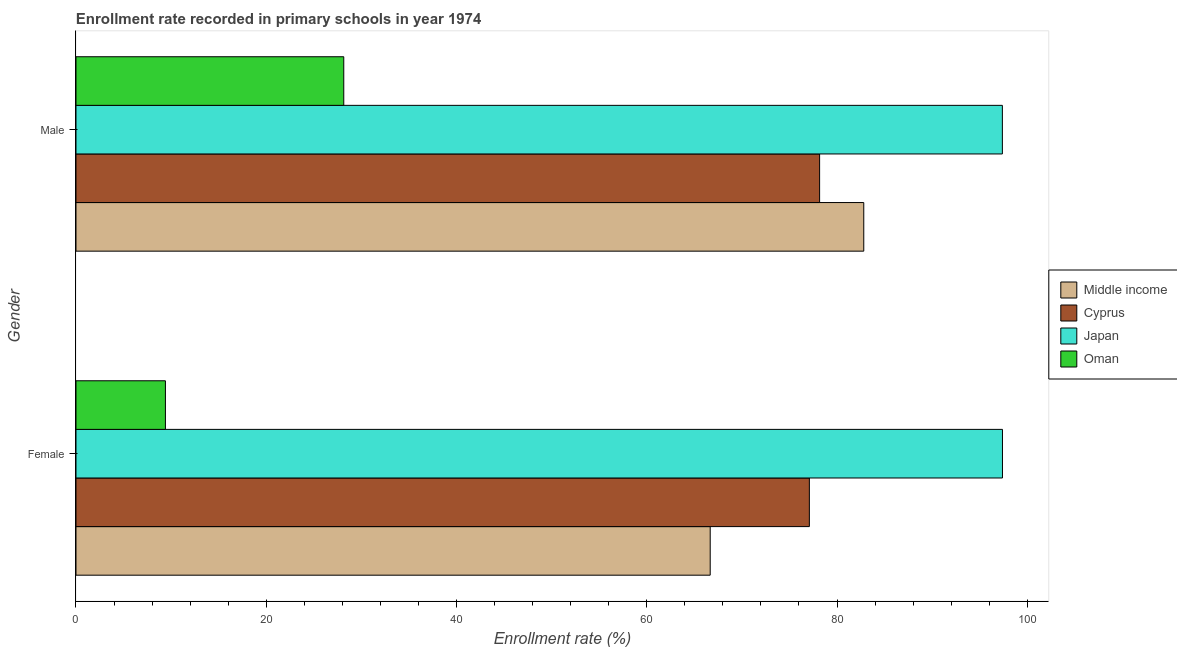How many bars are there on the 1st tick from the top?
Offer a terse response. 4. What is the label of the 1st group of bars from the top?
Your answer should be very brief. Male. What is the enrollment rate of female students in Cyprus?
Offer a very short reply. 77.09. Across all countries, what is the maximum enrollment rate of female students?
Ensure brevity in your answer.  97.39. Across all countries, what is the minimum enrollment rate of male students?
Ensure brevity in your answer.  28.15. In which country was the enrollment rate of male students minimum?
Offer a terse response. Oman. What is the total enrollment rate of female students in the graph?
Keep it short and to the point. 250.55. What is the difference between the enrollment rate of male students in Cyprus and that in Oman?
Offer a terse response. 50.02. What is the difference between the enrollment rate of male students in Middle income and the enrollment rate of female students in Cyprus?
Offer a terse response. 5.72. What is the average enrollment rate of female students per country?
Keep it short and to the point. 62.64. What is the difference between the enrollment rate of female students and enrollment rate of male students in Japan?
Your response must be concise. 0.01. In how many countries, is the enrollment rate of male students greater than 28 %?
Make the answer very short. 4. What is the ratio of the enrollment rate of male students in Cyprus to that in Middle income?
Offer a very short reply. 0.94. Is the enrollment rate of male students in Cyprus less than that in Japan?
Provide a succinct answer. Yes. In how many countries, is the enrollment rate of female students greater than the average enrollment rate of female students taken over all countries?
Your response must be concise. 3. How many bars are there?
Provide a short and direct response. 8. Are all the bars in the graph horizontal?
Your answer should be very brief. Yes. Are the values on the major ticks of X-axis written in scientific E-notation?
Ensure brevity in your answer.  No. Does the graph contain grids?
Ensure brevity in your answer.  No. How many legend labels are there?
Keep it short and to the point. 4. What is the title of the graph?
Provide a succinct answer. Enrollment rate recorded in primary schools in year 1974. What is the label or title of the X-axis?
Your answer should be very brief. Enrollment rate (%). What is the label or title of the Y-axis?
Give a very brief answer. Gender. What is the Enrollment rate (%) of Middle income in Female?
Provide a succinct answer. 66.67. What is the Enrollment rate (%) in Cyprus in Female?
Provide a short and direct response. 77.09. What is the Enrollment rate (%) of Japan in Female?
Provide a short and direct response. 97.39. What is the Enrollment rate (%) of Oman in Female?
Provide a succinct answer. 9.4. What is the Enrollment rate (%) of Middle income in Male?
Give a very brief answer. 82.81. What is the Enrollment rate (%) of Cyprus in Male?
Provide a short and direct response. 78.17. What is the Enrollment rate (%) of Japan in Male?
Make the answer very short. 97.38. What is the Enrollment rate (%) in Oman in Male?
Offer a terse response. 28.15. Across all Gender, what is the maximum Enrollment rate (%) of Middle income?
Provide a succinct answer. 82.81. Across all Gender, what is the maximum Enrollment rate (%) in Cyprus?
Make the answer very short. 78.17. Across all Gender, what is the maximum Enrollment rate (%) of Japan?
Provide a short and direct response. 97.39. Across all Gender, what is the maximum Enrollment rate (%) in Oman?
Your response must be concise. 28.15. Across all Gender, what is the minimum Enrollment rate (%) in Middle income?
Your answer should be very brief. 66.67. Across all Gender, what is the minimum Enrollment rate (%) of Cyprus?
Offer a terse response. 77.09. Across all Gender, what is the minimum Enrollment rate (%) of Japan?
Provide a succinct answer. 97.38. Across all Gender, what is the minimum Enrollment rate (%) of Oman?
Provide a succinct answer. 9.4. What is the total Enrollment rate (%) in Middle income in the graph?
Offer a very short reply. 149.48. What is the total Enrollment rate (%) of Cyprus in the graph?
Your answer should be very brief. 155.26. What is the total Enrollment rate (%) of Japan in the graph?
Ensure brevity in your answer.  194.77. What is the total Enrollment rate (%) of Oman in the graph?
Offer a terse response. 37.55. What is the difference between the Enrollment rate (%) of Middle income in Female and that in Male?
Offer a very short reply. -16.14. What is the difference between the Enrollment rate (%) of Cyprus in Female and that in Male?
Make the answer very short. -1.08. What is the difference between the Enrollment rate (%) in Japan in Female and that in Male?
Ensure brevity in your answer.  0.01. What is the difference between the Enrollment rate (%) of Oman in Female and that in Male?
Provide a short and direct response. -18.75. What is the difference between the Enrollment rate (%) in Middle income in Female and the Enrollment rate (%) in Japan in Male?
Offer a very short reply. -30.71. What is the difference between the Enrollment rate (%) of Middle income in Female and the Enrollment rate (%) of Oman in Male?
Ensure brevity in your answer.  38.52. What is the difference between the Enrollment rate (%) of Cyprus in Female and the Enrollment rate (%) of Japan in Male?
Your answer should be very brief. -20.29. What is the difference between the Enrollment rate (%) of Cyprus in Female and the Enrollment rate (%) of Oman in Male?
Give a very brief answer. 48.94. What is the difference between the Enrollment rate (%) in Japan in Female and the Enrollment rate (%) in Oman in Male?
Provide a succinct answer. 69.24. What is the average Enrollment rate (%) of Middle income per Gender?
Your answer should be very brief. 74.74. What is the average Enrollment rate (%) in Cyprus per Gender?
Provide a succinct answer. 77.63. What is the average Enrollment rate (%) of Japan per Gender?
Offer a very short reply. 97.39. What is the average Enrollment rate (%) of Oman per Gender?
Your response must be concise. 18.77. What is the difference between the Enrollment rate (%) in Middle income and Enrollment rate (%) in Cyprus in Female?
Your answer should be very brief. -10.42. What is the difference between the Enrollment rate (%) in Middle income and Enrollment rate (%) in Japan in Female?
Your response must be concise. -30.72. What is the difference between the Enrollment rate (%) in Middle income and Enrollment rate (%) in Oman in Female?
Offer a terse response. 57.27. What is the difference between the Enrollment rate (%) of Cyprus and Enrollment rate (%) of Japan in Female?
Your answer should be compact. -20.3. What is the difference between the Enrollment rate (%) of Cyprus and Enrollment rate (%) of Oman in Female?
Keep it short and to the point. 67.69. What is the difference between the Enrollment rate (%) of Japan and Enrollment rate (%) of Oman in Female?
Provide a short and direct response. 87.99. What is the difference between the Enrollment rate (%) in Middle income and Enrollment rate (%) in Cyprus in Male?
Make the answer very short. 4.64. What is the difference between the Enrollment rate (%) of Middle income and Enrollment rate (%) of Japan in Male?
Offer a very short reply. -14.57. What is the difference between the Enrollment rate (%) in Middle income and Enrollment rate (%) in Oman in Male?
Your response must be concise. 54.66. What is the difference between the Enrollment rate (%) of Cyprus and Enrollment rate (%) of Japan in Male?
Provide a short and direct response. -19.21. What is the difference between the Enrollment rate (%) of Cyprus and Enrollment rate (%) of Oman in Male?
Provide a succinct answer. 50.02. What is the difference between the Enrollment rate (%) in Japan and Enrollment rate (%) in Oman in Male?
Give a very brief answer. 69.23. What is the ratio of the Enrollment rate (%) in Middle income in Female to that in Male?
Offer a very short reply. 0.81. What is the ratio of the Enrollment rate (%) in Cyprus in Female to that in Male?
Provide a succinct answer. 0.99. What is the ratio of the Enrollment rate (%) in Japan in Female to that in Male?
Provide a succinct answer. 1. What is the ratio of the Enrollment rate (%) in Oman in Female to that in Male?
Offer a very short reply. 0.33. What is the difference between the highest and the second highest Enrollment rate (%) of Middle income?
Make the answer very short. 16.14. What is the difference between the highest and the second highest Enrollment rate (%) in Cyprus?
Offer a very short reply. 1.08. What is the difference between the highest and the second highest Enrollment rate (%) of Japan?
Your answer should be compact. 0.01. What is the difference between the highest and the second highest Enrollment rate (%) in Oman?
Give a very brief answer. 18.75. What is the difference between the highest and the lowest Enrollment rate (%) of Middle income?
Your answer should be very brief. 16.14. What is the difference between the highest and the lowest Enrollment rate (%) in Cyprus?
Your answer should be very brief. 1.08. What is the difference between the highest and the lowest Enrollment rate (%) in Japan?
Offer a terse response. 0.01. What is the difference between the highest and the lowest Enrollment rate (%) of Oman?
Make the answer very short. 18.75. 